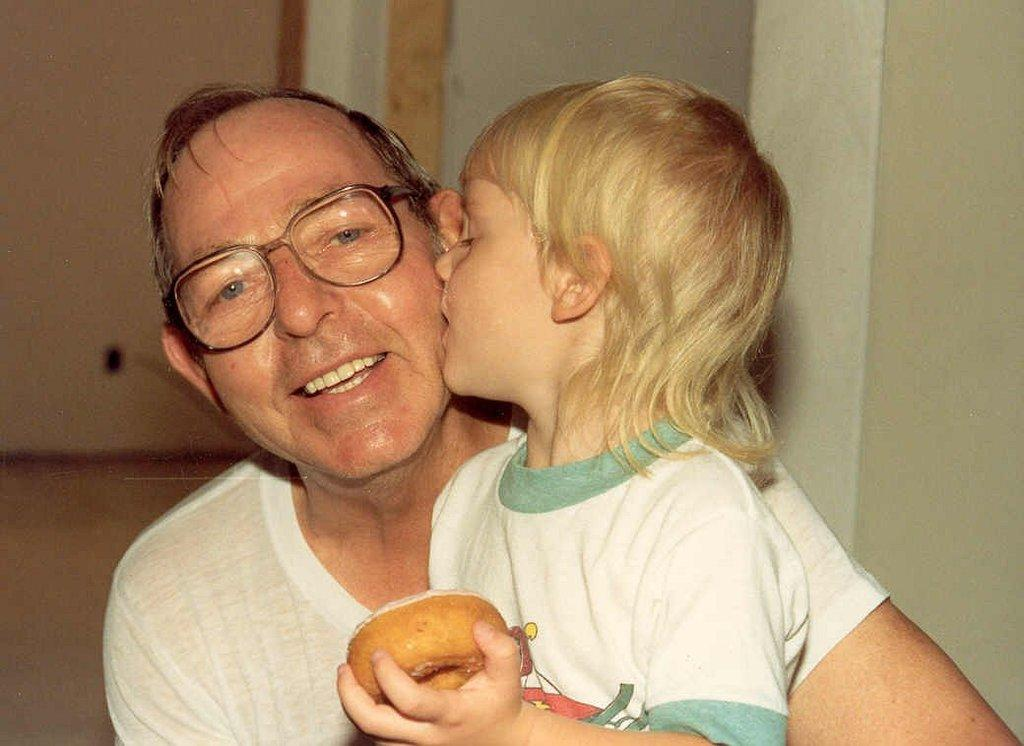What is the person in the image doing with the kid? The person is holding the kid in the image. What is the kid holding in the image? The kid is holding a doughnut. What can be seen in the background of the image? There is a wall in the background of the image. What type of kite is the kid flying in the image? There is no kite present in the image; the kid is holding a doughnut. 